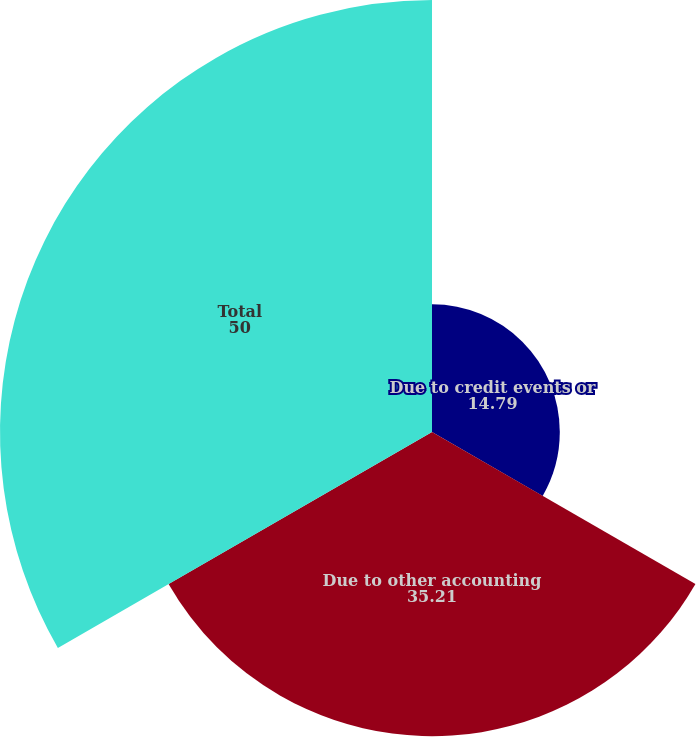Convert chart to OTSL. <chart><loc_0><loc_0><loc_500><loc_500><pie_chart><fcel>Due to credit events or<fcel>Due to other accounting<fcel>Total<nl><fcel>14.79%<fcel>35.21%<fcel>50.0%<nl></chart> 